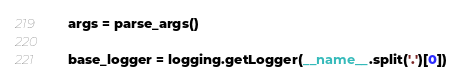Convert code to text. <code><loc_0><loc_0><loc_500><loc_500><_Python_>    args = parse_args()

    base_logger = logging.getLogger(__name__.split('.')[0])</code> 